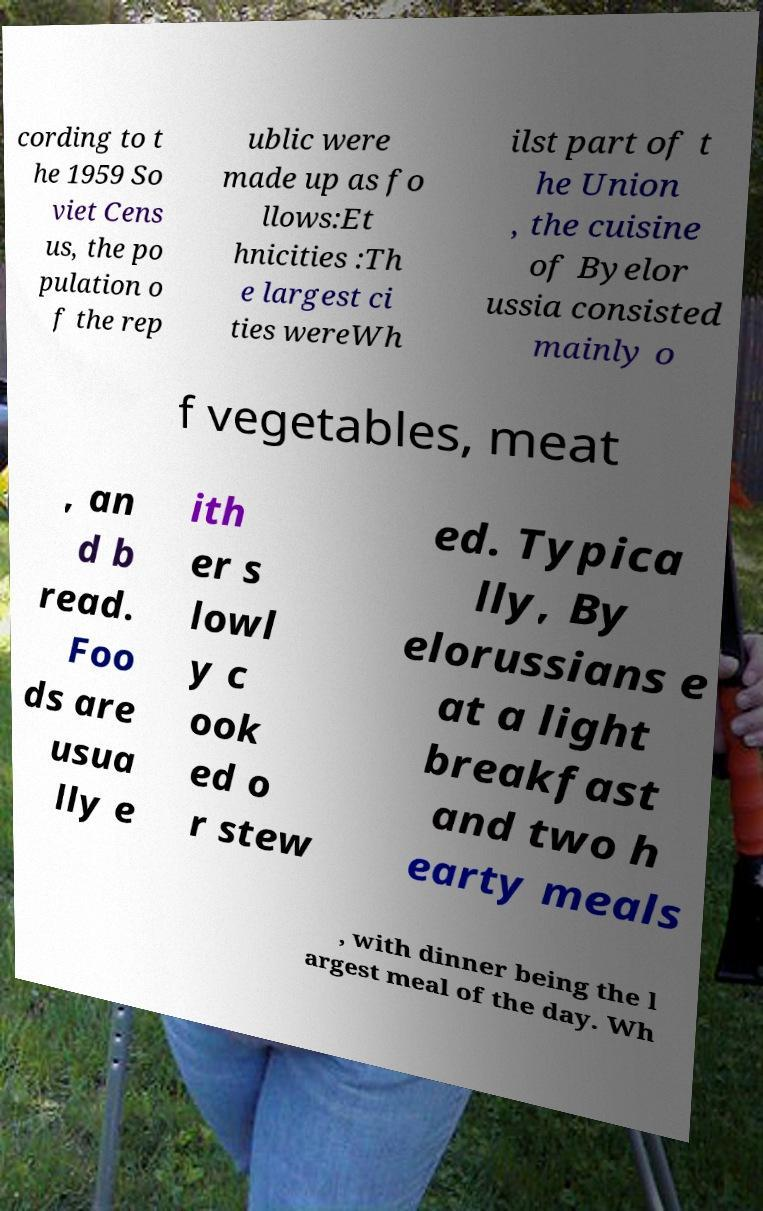For documentation purposes, I need the text within this image transcribed. Could you provide that? cording to t he 1959 So viet Cens us, the po pulation o f the rep ublic were made up as fo llows:Et hnicities :Th e largest ci ties wereWh ilst part of t he Union , the cuisine of Byelor ussia consisted mainly o f vegetables, meat , an d b read. Foo ds are usua lly e ith er s lowl y c ook ed o r stew ed. Typica lly, By elorussians e at a light breakfast and two h earty meals , with dinner being the l argest meal of the day. Wh 